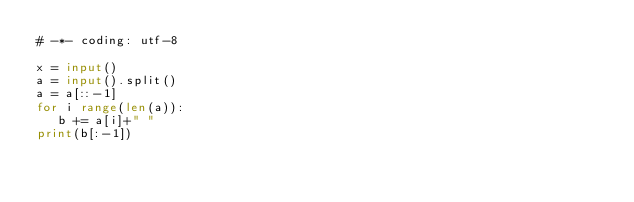<code> <loc_0><loc_0><loc_500><loc_500><_Python_># -*- coding: utf-8

x = input()
a = input().split()
a = a[::-1]
for i range(len(a)):
   b += a[i]+" "
print(b[:-1])

</code> 